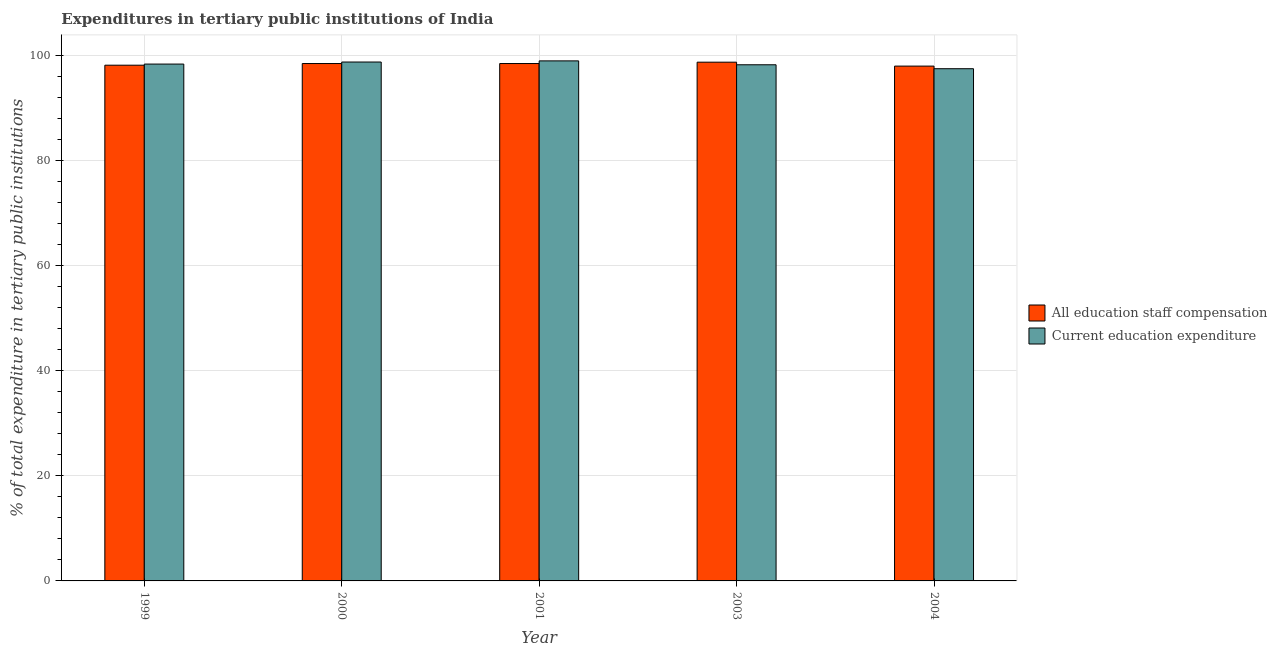Are the number of bars per tick equal to the number of legend labels?
Offer a very short reply. Yes. What is the label of the 2nd group of bars from the left?
Offer a terse response. 2000. In how many cases, is the number of bars for a given year not equal to the number of legend labels?
Offer a terse response. 0. What is the expenditure in education in 2003?
Provide a short and direct response. 98.3. Across all years, what is the maximum expenditure in education?
Give a very brief answer. 99.04. Across all years, what is the minimum expenditure in education?
Ensure brevity in your answer.  97.55. In which year was the expenditure in staff compensation maximum?
Keep it short and to the point. 2003. In which year was the expenditure in staff compensation minimum?
Make the answer very short. 2004. What is the total expenditure in staff compensation in the graph?
Make the answer very short. 492.1. What is the difference between the expenditure in staff compensation in 2000 and that in 2003?
Offer a terse response. -0.26. What is the difference between the expenditure in education in 2001 and the expenditure in staff compensation in 1999?
Ensure brevity in your answer.  0.61. What is the average expenditure in education per year?
Provide a succinct answer. 98.43. In the year 2000, what is the difference between the expenditure in staff compensation and expenditure in education?
Offer a very short reply. 0. In how many years, is the expenditure in staff compensation greater than 36 %?
Offer a very short reply. 5. What is the ratio of the expenditure in staff compensation in 1999 to that in 2001?
Your answer should be compact. 1. Is the expenditure in staff compensation in 2001 less than that in 2003?
Provide a short and direct response. Yes. What is the difference between the highest and the second highest expenditure in staff compensation?
Your response must be concise. 0.26. What is the difference between the highest and the lowest expenditure in staff compensation?
Offer a very short reply. 0.75. What does the 2nd bar from the left in 1999 represents?
Offer a terse response. Current education expenditure. What does the 2nd bar from the right in 1999 represents?
Offer a terse response. All education staff compensation. How many bars are there?
Keep it short and to the point. 10. How many years are there in the graph?
Offer a very short reply. 5. Are the values on the major ticks of Y-axis written in scientific E-notation?
Make the answer very short. No. Does the graph contain grids?
Give a very brief answer. Yes. Where does the legend appear in the graph?
Provide a short and direct response. Center right. What is the title of the graph?
Keep it short and to the point. Expenditures in tertiary public institutions of India. Does "Investment in Telecom" appear as one of the legend labels in the graph?
Make the answer very short. No. What is the label or title of the Y-axis?
Provide a succinct answer. % of total expenditure in tertiary public institutions. What is the % of total expenditure in tertiary public institutions in All education staff compensation in 1999?
Provide a succinct answer. 98.21. What is the % of total expenditure in tertiary public institutions in Current education expenditure in 1999?
Keep it short and to the point. 98.43. What is the % of total expenditure in tertiary public institutions in All education staff compensation in 2000?
Give a very brief answer. 98.53. What is the % of total expenditure in tertiary public institutions in Current education expenditure in 2000?
Offer a terse response. 98.82. What is the % of total expenditure in tertiary public institutions in All education staff compensation in 2001?
Your answer should be compact. 98.53. What is the % of total expenditure in tertiary public institutions of Current education expenditure in 2001?
Your answer should be compact. 99.04. What is the % of total expenditure in tertiary public institutions of All education staff compensation in 2003?
Keep it short and to the point. 98.79. What is the % of total expenditure in tertiary public institutions in Current education expenditure in 2003?
Provide a succinct answer. 98.3. What is the % of total expenditure in tertiary public institutions of All education staff compensation in 2004?
Ensure brevity in your answer.  98.04. What is the % of total expenditure in tertiary public institutions of Current education expenditure in 2004?
Offer a very short reply. 97.55. Across all years, what is the maximum % of total expenditure in tertiary public institutions of All education staff compensation?
Your answer should be compact. 98.79. Across all years, what is the maximum % of total expenditure in tertiary public institutions in Current education expenditure?
Your response must be concise. 99.04. Across all years, what is the minimum % of total expenditure in tertiary public institutions of All education staff compensation?
Your answer should be very brief. 98.04. Across all years, what is the minimum % of total expenditure in tertiary public institutions of Current education expenditure?
Ensure brevity in your answer.  97.55. What is the total % of total expenditure in tertiary public institutions of All education staff compensation in the graph?
Provide a succinct answer. 492.1. What is the total % of total expenditure in tertiary public institutions in Current education expenditure in the graph?
Offer a very short reply. 492.13. What is the difference between the % of total expenditure in tertiary public institutions in All education staff compensation in 1999 and that in 2000?
Ensure brevity in your answer.  -0.32. What is the difference between the % of total expenditure in tertiary public institutions in Current education expenditure in 1999 and that in 2000?
Your answer should be compact. -0.39. What is the difference between the % of total expenditure in tertiary public institutions of All education staff compensation in 1999 and that in 2001?
Make the answer very short. -0.32. What is the difference between the % of total expenditure in tertiary public institutions in Current education expenditure in 1999 and that in 2001?
Offer a very short reply. -0.61. What is the difference between the % of total expenditure in tertiary public institutions in All education staff compensation in 1999 and that in 2003?
Your answer should be very brief. -0.58. What is the difference between the % of total expenditure in tertiary public institutions in Current education expenditure in 1999 and that in 2003?
Your answer should be compact. 0.13. What is the difference between the % of total expenditure in tertiary public institutions in All education staff compensation in 1999 and that in 2004?
Offer a terse response. 0.17. What is the difference between the % of total expenditure in tertiary public institutions of Current education expenditure in 1999 and that in 2004?
Your answer should be compact. 0.88. What is the difference between the % of total expenditure in tertiary public institutions of Current education expenditure in 2000 and that in 2001?
Your response must be concise. -0.22. What is the difference between the % of total expenditure in tertiary public institutions in All education staff compensation in 2000 and that in 2003?
Offer a terse response. -0.26. What is the difference between the % of total expenditure in tertiary public institutions of Current education expenditure in 2000 and that in 2003?
Offer a terse response. 0.52. What is the difference between the % of total expenditure in tertiary public institutions of All education staff compensation in 2000 and that in 2004?
Your response must be concise. 0.49. What is the difference between the % of total expenditure in tertiary public institutions in Current education expenditure in 2000 and that in 2004?
Your answer should be very brief. 1.27. What is the difference between the % of total expenditure in tertiary public institutions of All education staff compensation in 2001 and that in 2003?
Make the answer very short. -0.26. What is the difference between the % of total expenditure in tertiary public institutions of Current education expenditure in 2001 and that in 2003?
Your answer should be compact. 0.74. What is the difference between the % of total expenditure in tertiary public institutions in All education staff compensation in 2001 and that in 2004?
Your answer should be very brief. 0.49. What is the difference between the % of total expenditure in tertiary public institutions of Current education expenditure in 2001 and that in 2004?
Your answer should be compact. 1.49. What is the difference between the % of total expenditure in tertiary public institutions of All education staff compensation in 2003 and that in 2004?
Keep it short and to the point. 0.75. What is the difference between the % of total expenditure in tertiary public institutions of Current education expenditure in 2003 and that in 2004?
Your answer should be very brief. 0.75. What is the difference between the % of total expenditure in tertiary public institutions of All education staff compensation in 1999 and the % of total expenditure in tertiary public institutions of Current education expenditure in 2000?
Provide a succinct answer. -0.61. What is the difference between the % of total expenditure in tertiary public institutions of All education staff compensation in 1999 and the % of total expenditure in tertiary public institutions of Current education expenditure in 2001?
Make the answer very short. -0.82. What is the difference between the % of total expenditure in tertiary public institutions in All education staff compensation in 1999 and the % of total expenditure in tertiary public institutions in Current education expenditure in 2003?
Make the answer very short. -0.08. What is the difference between the % of total expenditure in tertiary public institutions of All education staff compensation in 1999 and the % of total expenditure in tertiary public institutions of Current education expenditure in 2004?
Your answer should be very brief. 0.67. What is the difference between the % of total expenditure in tertiary public institutions in All education staff compensation in 2000 and the % of total expenditure in tertiary public institutions in Current education expenditure in 2001?
Offer a terse response. -0.51. What is the difference between the % of total expenditure in tertiary public institutions of All education staff compensation in 2000 and the % of total expenditure in tertiary public institutions of Current education expenditure in 2003?
Provide a succinct answer. 0.23. What is the difference between the % of total expenditure in tertiary public institutions of All education staff compensation in 2000 and the % of total expenditure in tertiary public institutions of Current education expenditure in 2004?
Keep it short and to the point. 0.98. What is the difference between the % of total expenditure in tertiary public institutions of All education staff compensation in 2001 and the % of total expenditure in tertiary public institutions of Current education expenditure in 2003?
Your answer should be very brief. 0.23. What is the difference between the % of total expenditure in tertiary public institutions in All education staff compensation in 2001 and the % of total expenditure in tertiary public institutions in Current education expenditure in 2004?
Offer a terse response. 0.98. What is the difference between the % of total expenditure in tertiary public institutions in All education staff compensation in 2003 and the % of total expenditure in tertiary public institutions in Current education expenditure in 2004?
Offer a very short reply. 1.24. What is the average % of total expenditure in tertiary public institutions in All education staff compensation per year?
Your response must be concise. 98.42. What is the average % of total expenditure in tertiary public institutions of Current education expenditure per year?
Provide a succinct answer. 98.43. In the year 1999, what is the difference between the % of total expenditure in tertiary public institutions in All education staff compensation and % of total expenditure in tertiary public institutions in Current education expenditure?
Make the answer very short. -0.22. In the year 2000, what is the difference between the % of total expenditure in tertiary public institutions in All education staff compensation and % of total expenditure in tertiary public institutions in Current education expenditure?
Ensure brevity in your answer.  -0.29. In the year 2001, what is the difference between the % of total expenditure in tertiary public institutions in All education staff compensation and % of total expenditure in tertiary public institutions in Current education expenditure?
Offer a terse response. -0.51. In the year 2003, what is the difference between the % of total expenditure in tertiary public institutions in All education staff compensation and % of total expenditure in tertiary public institutions in Current education expenditure?
Keep it short and to the point. 0.49. In the year 2004, what is the difference between the % of total expenditure in tertiary public institutions of All education staff compensation and % of total expenditure in tertiary public institutions of Current education expenditure?
Offer a very short reply. 0.5. What is the ratio of the % of total expenditure in tertiary public institutions of All education staff compensation in 1999 to that in 2000?
Keep it short and to the point. 1. What is the ratio of the % of total expenditure in tertiary public institutions in Current education expenditure in 1999 to that in 2000?
Make the answer very short. 1. What is the ratio of the % of total expenditure in tertiary public institutions in All education staff compensation in 1999 to that in 2001?
Keep it short and to the point. 1. What is the ratio of the % of total expenditure in tertiary public institutions of Current education expenditure in 1999 to that in 2003?
Give a very brief answer. 1. What is the ratio of the % of total expenditure in tertiary public institutions in All education staff compensation in 1999 to that in 2004?
Offer a very short reply. 1. What is the ratio of the % of total expenditure in tertiary public institutions of Current education expenditure in 1999 to that in 2004?
Provide a short and direct response. 1.01. What is the ratio of the % of total expenditure in tertiary public institutions in All education staff compensation in 2000 to that in 2003?
Offer a terse response. 1. What is the ratio of the % of total expenditure in tertiary public institutions of Current education expenditure in 2000 to that in 2003?
Your answer should be compact. 1.01. What is the ratio of the % of total expenditure in tertiary public institutions in Current education expenditure in 2000 to that in 2004?
Your answer should be compact. 1.01. What is the ratio of the % of total expenditure in tertiary public institutions in Current education expenditure in 2001 to that in 2003?
Your response must be concise. 1.01. What is the ratio of the % of total expenditure in tertiary public institutions in All education staff compensation in 2001 to that in 2004?
Your answer should be compact. 1. What is the ratio of the % of total expenditure in tertiary public institutions in Current education expenditure in 2001 to that in 2004?
Give a very brief answer. 1.02. What is the ratio of the % of total expenditure in tertiary public institutions in All education staff compensation in 2003 to that in 2004?
Provide a short and direct response. 1.01. What is the ratio of the % of total expenditure in tertiary public institutions of Current education expenditure in 2003 to that in 2004?
Make the answer very short. 1.01. What is the difference between the highest and the second highest % of total expenditure in tertiary public institutions in All education staff compensation?
Your answer should be very brief. 0.26. What is the difference between the highest and the second highest % of total expenditure in tertiary public institutions in Current education expenditure?
Make the answer very short. 0.22. What is the difference between the highest and the lowest % of total expenditure in tertiary public institutions in All education staff compensation?
Keep it short and to the point. 0.75. What is the difference between the highest and the lowest % of total expenditure in tertiary public institutions of Current education expenditure?
Your response must be concise. 1.49. 